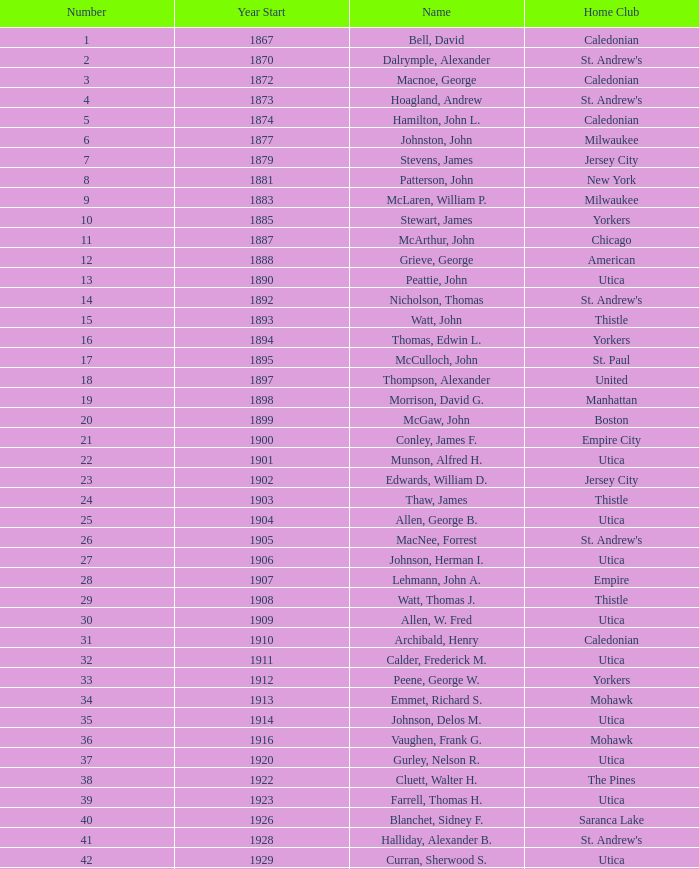Which Number has a Year Start smaller than 1874, and a Year End larger than 1873? 4.0. 